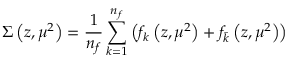Convert formula to latex. <formula><loc_0><loc_0><loc_500><loc_500>\Sigma \left ( z , \mu ^ { 2 } \right ) = \frac { 1 } { n _ { f } } \sum _ { k = 1 } ^ { n _ { f } } \left ( f _ { k } \left ( z , \mu ^ { 2 } \right ) + f _ { \bar { k } } \left ( z , \mu ^ { 2 } \right ) \right )</formula> 